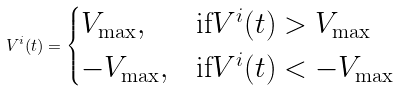Convert formula to latex. <formula><loc_0><loc_0><loc_500><loc_500>V ^ { i } ( t ) = \begin{cases} V _ { \max } , & \text {if} V ^ { i } ( t ) > V _ { \max } \\ - V _ { \max } , & \text {if} V ^ { i } ( t ) < - V _ { \max } \end{cases}</formula> 